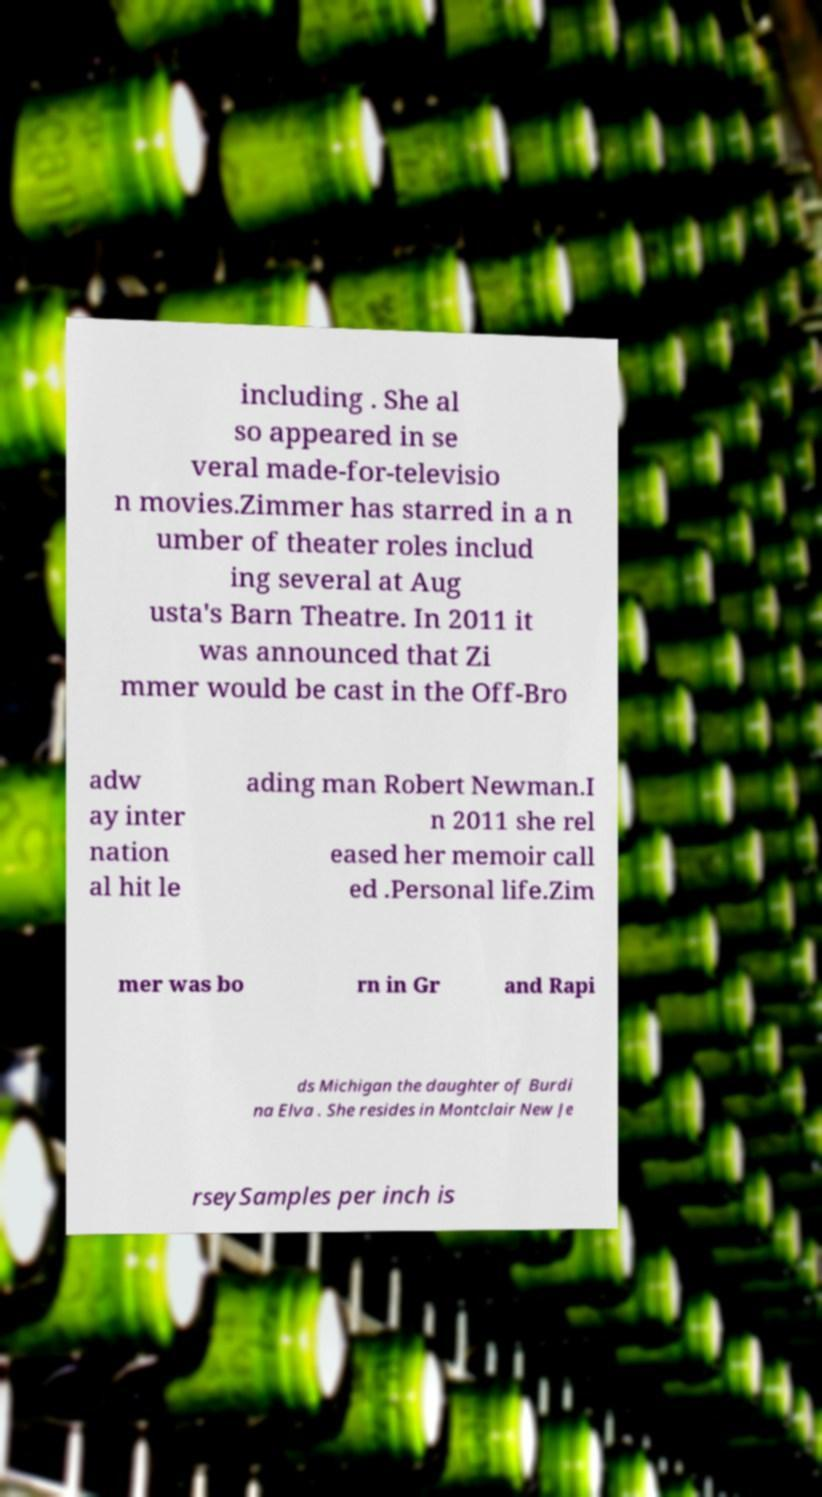What messages or text are displayed in this image? I need them in a readable, typed format. including . She al so appeared in se veral made-for-televisio n movies.Zimmer has starred in a n umber of theater roles includ ing several at Aug usta's Barn Theatre. In 2011 it was announced that Zi mmer would be cast in the Off-Bro adw ay inter nation al hit le ading man Robert Newman.I n 2011 she rel eased her memoir call ed .Personal life.Zim mer was bo rn in Gr and Rapi ds Michigan the daughter of Burdi na Elva . She resides in Montclair New Je rseySamples per inch is 